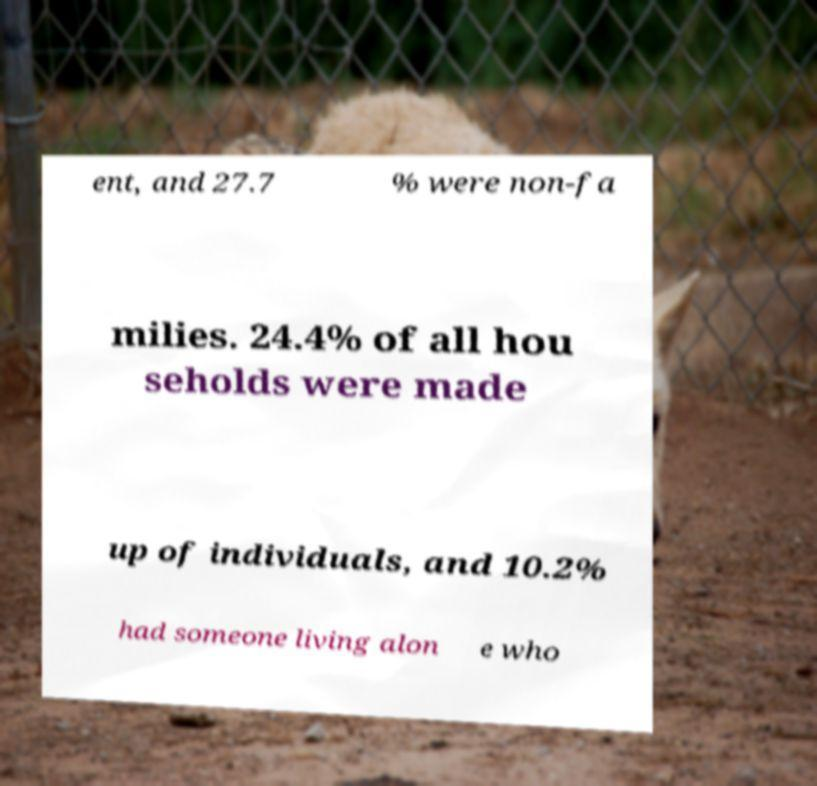For documentation purposes, I need the text within this image transcribed. Could you provide that? ent, and 27.7 % were non-fa milies. 24.4% of all hou seholds were made up of individuals, and 10.2% had someone living alon e who 